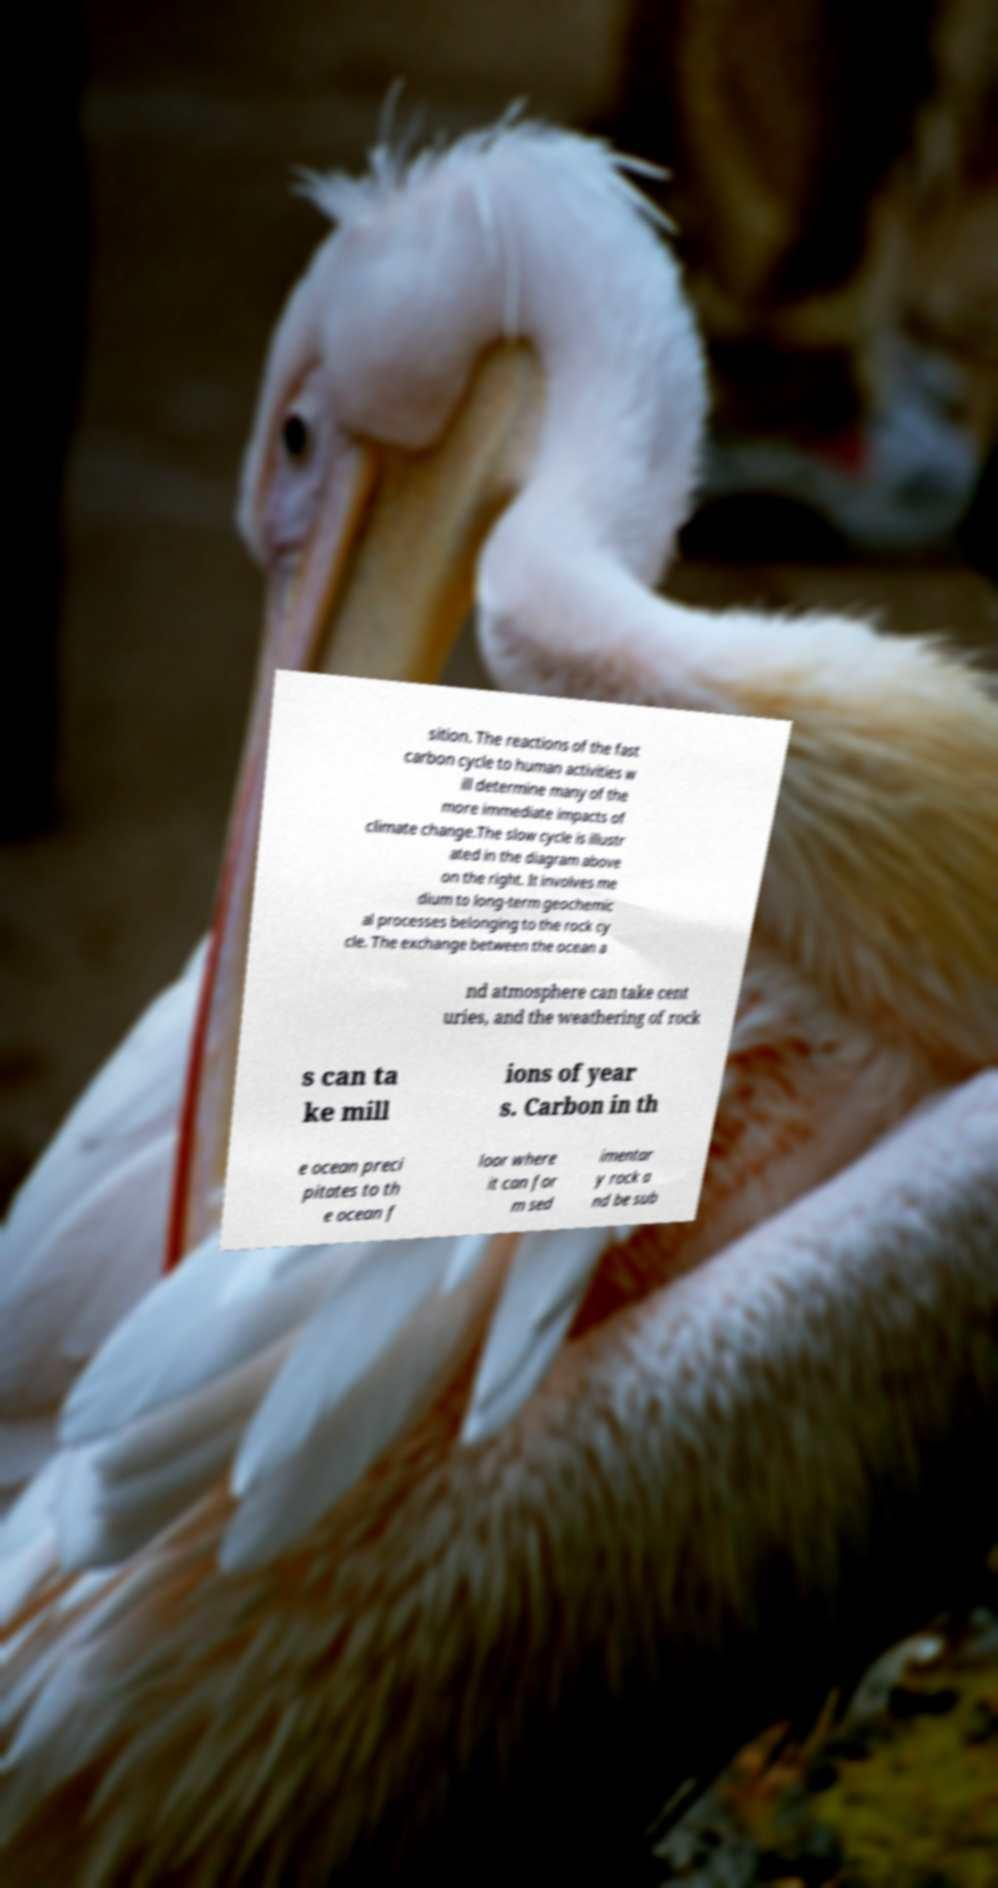What messages or text are displayed in this image? I need them in a readable, typed format. sition. The reactions of the fast carbon cycle to human activities w ill determine many of the more immediate impacts of climate change.The slow cycle is illustr ated in the diagram above on the right. It involves me dium to long-term geochemic al processes belonging to the rock cy cle. The exchange between the ocean a nd atmosphere can take cent uries, and the weathering of rock s can ta ke mill ions of year s. Carbon in th e ocean preci pitates to th e ocean f loor where it can for m sed imentar y rock a nd be sub 